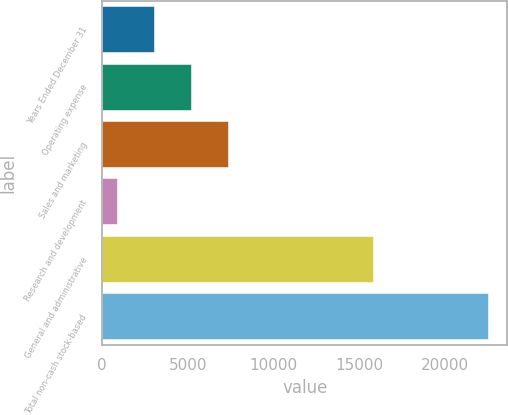Convert chart. <chart><loc_0><loc_0><loc_500><loc_500><bar_chart><fcel>Years Ended December 31<fcel>Operating expense<fcel>Sales and marketing<fcel>Research and development<fcel>General and administrative<fcel>Total non-cash stock-based<nl><fcel>3007<fcel>5178<fcel>7349<fcel>836<fcel>15837<fcel>22546<nl></chart> 